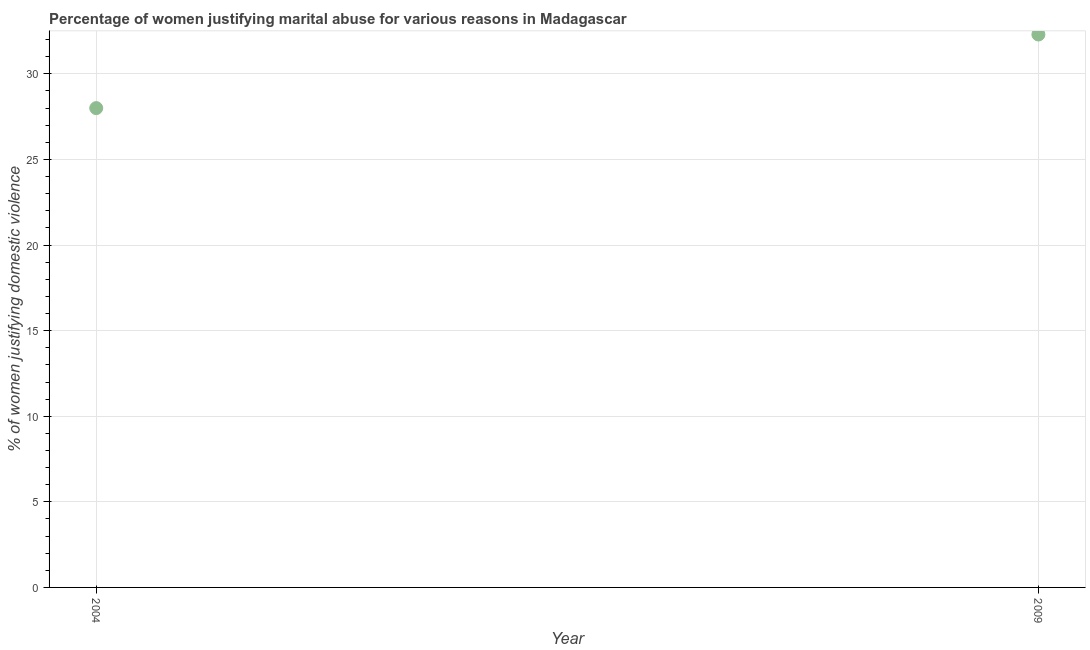Across all years, what is the maximum percentage of women justifying marital abuse?
Offer a terse response. 32.3. What is the sum of the percentage of women justifying marital abuse?
Your response must be concise. 60.3. What is the difference between the percentage of women justifying marital abuse in 2004 and 2009?
Your answer should be very brief. -4.3. What is the average percentage of women justifying marital abuse per year?
Give a very brief answer. 30.15. What is the median percentage of women justifying marital abuse?
Provide a short and direct response. 30.15. What is the ratio of the percentage of women justifying marital abuse in 2004 to that in 2009?
Your response must be concise. 0.87. Is the percentage of women justifying marital abuse in 2004 less than that in 2009?
Keep it short and to the point. Yes. In how many years, is the percentage of women justifying marital abuse greater than the average percentage of women justifying marital abuse taken over all years?
Provide a short and direct response. 1. How many years are there in the graph?
Offer a terse response. 2. What is the difference between two consecutive major ticks on the Y-axis?
Provide a short and direct response. 5. What is the title of the graph?
Your response must be concise. Percentage of women justifying marital abuse for various reasons in Madagascar. What is the label or title of the Y-axis?
Provide a short and direct response. % of women justifying domestic violence. What is the % of women justifying domestic violence in 2004?
Give a very brief answer. 28. What is the % of women justifying domestic violence in 2009?
Provide a short and direct response. 32.3. What is the ratio of the % of women justifying domestic violence in 2004 to that in 2009?
Your answer should be compact. 0.87. 